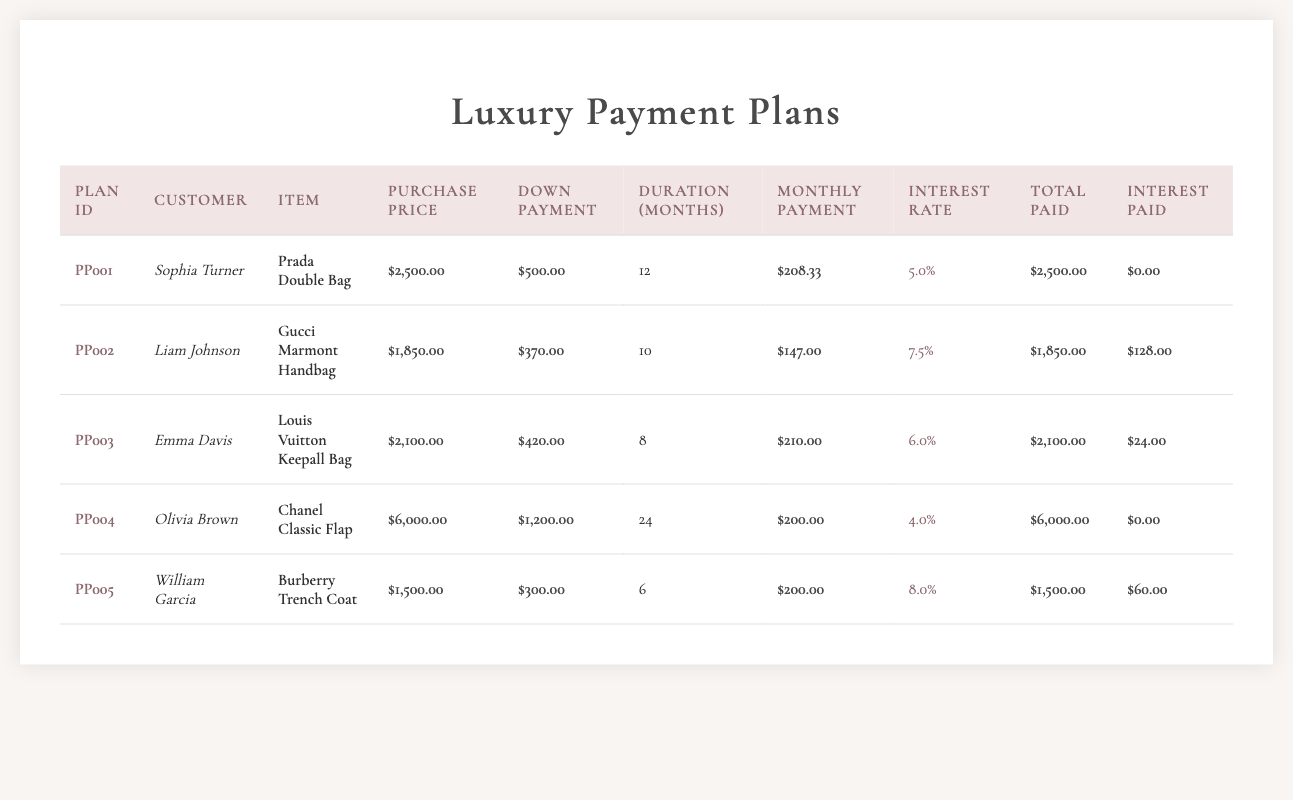What is the purchase price of the Prada Double Bag? From the table, the purchase price column shows that for the Prada Double Bag, the purchase price is $2,500.00.
Answer: $2,500.00 What is the total amount paid by Olivia Brown for her Chanel Classic Flap? The table indicates that the total amount paid by Olivia Brown for the Chanel Classic Flap is $6,000.00.
Answer: $6,000.00 How many months is the payment duration for Liam Johnson's Gucci Marmont Handbag? The payment duration for Liam Johnson's Gucci Marmont Handbag is clearly listed in the table as 10 months.
Answer: 10 months What is the average monthly payment across all payment plans? To find the average, sum the monthly payments of all plans: (208.33 + 147.00 + 210.00 + 200.00 + 200.00) = 1,065.33. There are 5 plans, so the average monthly payment is 1,065.33 / 5 = 213.07.
Answer: 213.07 Did William Garcia pay any interest? The total interest paid by William Garcia, as indicated in the table, is $60.00, which means he did pay interest.
Answer: Yes Which customer has the lowest interest rate? The interest rates listed in the table are as follows: 5.0% for Sophia Turner, 7.5% for Liam Johnson, 6.0% for Emma Davis, 4.0% for Olivia Brown, and 8.0% for William Garcia. The lowest rate is 4.0%, which belongs to Olivia Brown.
Answer: Olivia Brown How much total interest is paid compared to the purchase price for Emma Davis? For Emma Davis, the total interest paid is $24.00 and the purchase price is $2,100.00. To find the ratio of total interest to purchase price, divide total interest by purchase price: 24 / 2100 = 0.0114, or approximately 1.14%.
Answer: 1.14% What is the difference in total amount paid between the most expensive and the least expensive item? The most expensive item is the Chanel Classic Flap with a total paid of $6,000.00, and the least expensive item is the Gucci Marmont Handbag, with a total paid of $1,850.00. The difference is $6,000.00 - $1,850.00 = $4,150.00.
Answer: $4,150.00 What item did Sophia Turner purchase? According to the table, the item purchased by Sophia Turner is the Prada Double Bag.
Answer: Prada Double Bag 